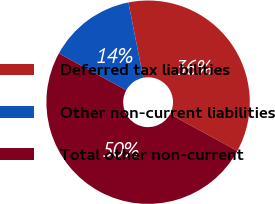Convert chart. <chart><loc_0><loc_0><loc_500><loc_500><pie_chart><fcel>Deferred tax liabilities<fcel>Other non-current liabilities<fcel>Total other non-current<nl><fcel>36.06%<fcel>13.94%<fcel>50.0%<nl></chart> 